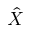Convert formula to latex. <formula><loc_0><loc_0><loc_500><loc_500>\hat { X }</formula> 